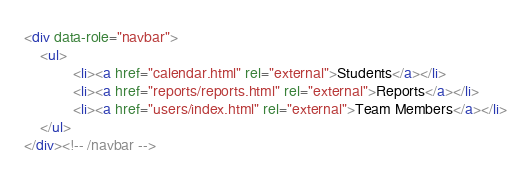Convert code to text. <code><loc_0><loc_0><loc_500><loc_500><_HTML_>
<div data-role="navbar">
	<ul>
            <li><a href="calendar.html" rel="external">Students</a></li>
            <li><a href="reports/reports.html" rel="external">Reports</a></li>
            <li><a href="users/index.html" rel="external">Team Members</a></li>
	</ul>
</div><!-- /navbar -->
</code> 